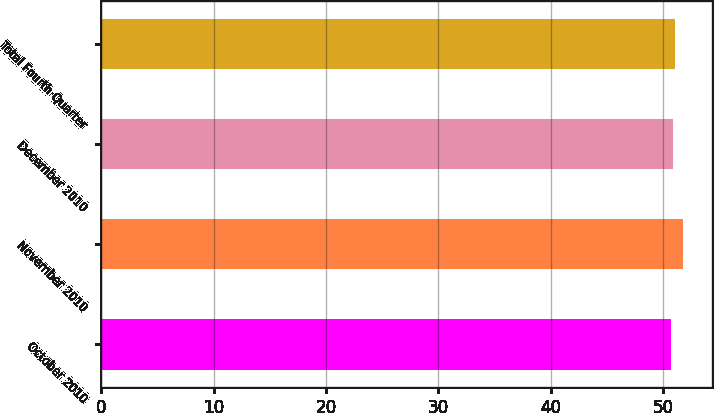Convert chart. <chart><loc_0><loc_0><loc_500><loc_500><bar_chart><fcel>October 2010<fcel>November 2010<fcel>December 2010<fcel>Total Fourth Quarter<nl><fcel>50.76<fcel>51.81<fcel>50.89<fcel>51.08<nl></chart> 